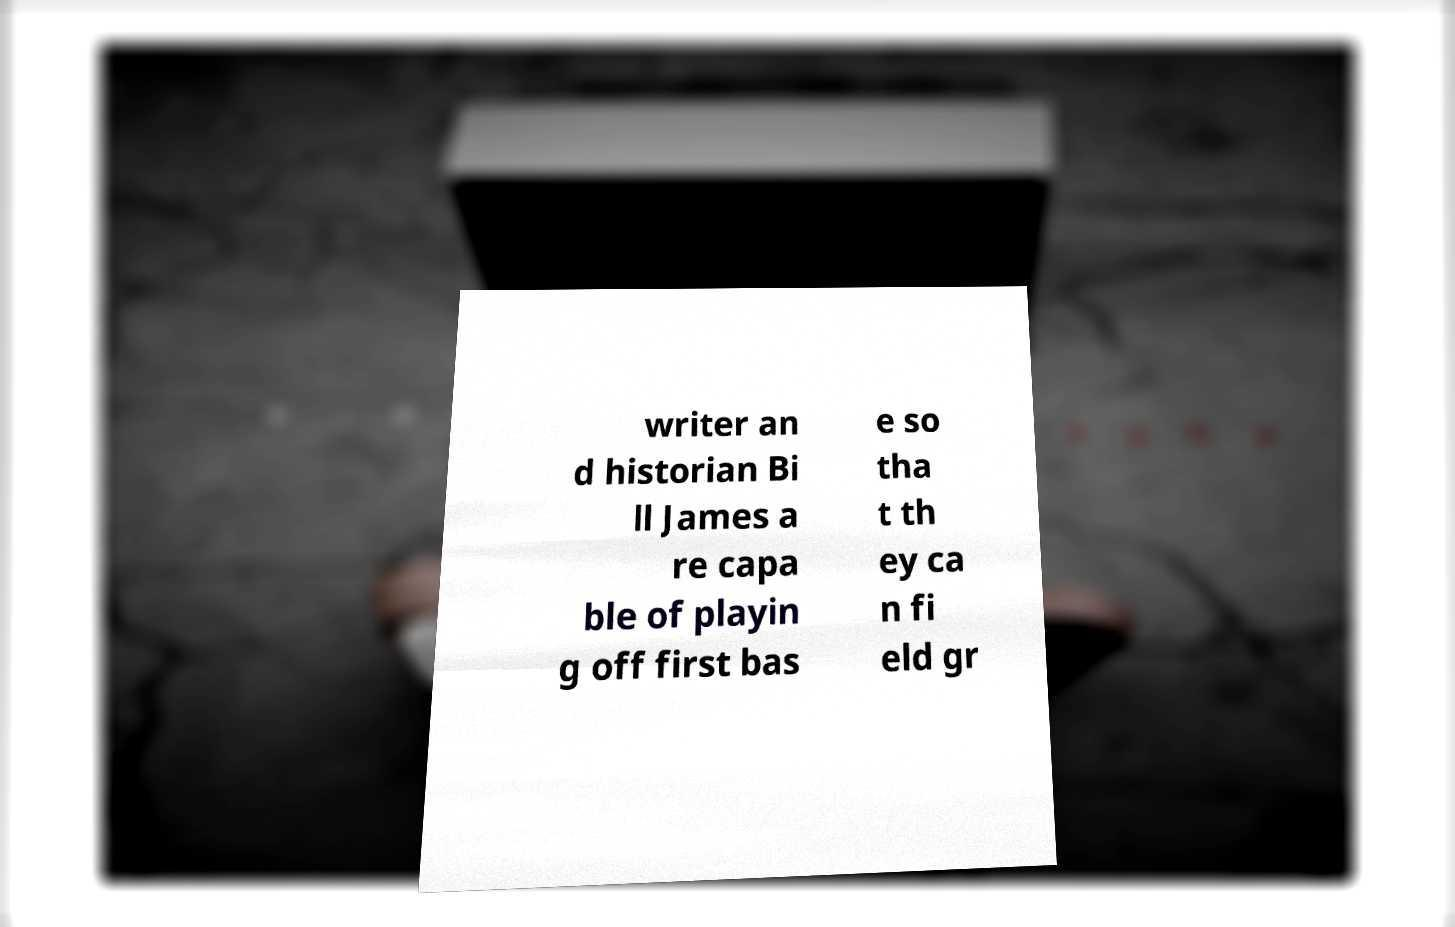What messages or text are displayed in this image? I need them in a readable, typed format. writer an d historian Bi ll James a re capa ble of playin g off first bas e so tha t th ey ca n fi eld gr 